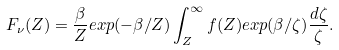Convert formula to latex. <formula><loc_0><loc_0><loc_500><loc_500>F _ { \nu } ( Z ) = \frac { \beta } { Z } e x p ( - \beta / Z ) \int ^ { \infty } _ { Z } f ( Z ) e x p ( \beta / \zeta ) \frac { d \zeta } { \zeta } .</formula> 